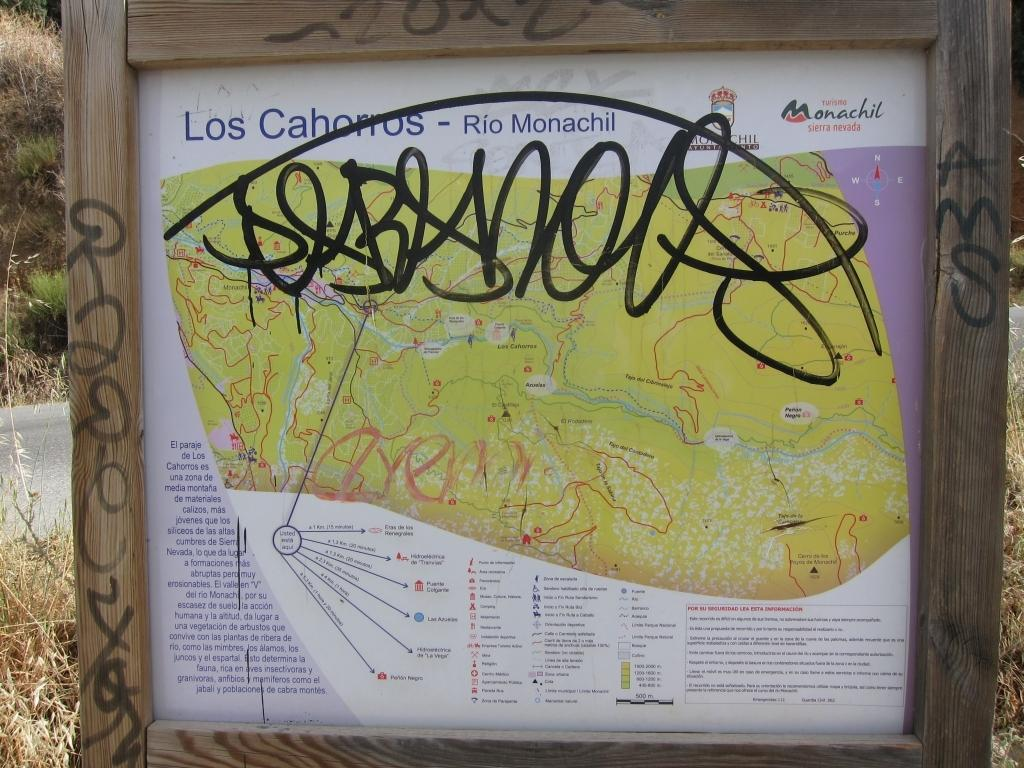<image>
Summarize the visual content of the image. A park map for Los Cahonos Rio Monachil. 